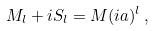Convert formula to latex. <formula><loc_0><loc_0><loc_500><loc_500>M _ { l } + i S _ { l } = M ( i a ) ^ { l } \, ,</formula> 